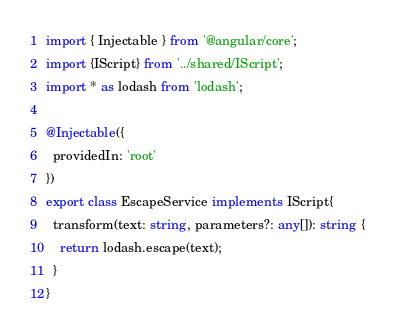<code> <loc_0><loc_0><loc_500><loc_500><_TypeScript_>import { Injectable } from '@angular/core';
import {IScript} from '../shared/IScript';
import * as lodash from 'lodash';

@Injectable({
  providedIn: 'root'
})
export class EscapeService implements IScript{
  transform(text: string, parameters?: any[]): string {
    return lodash.escape(text);
  }
}
</code> 